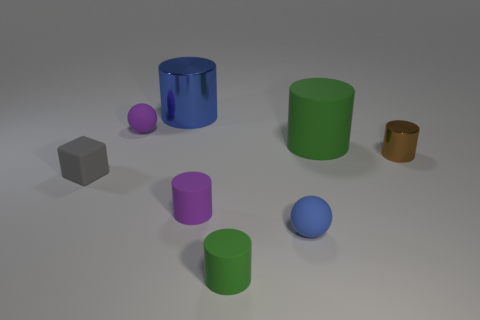How many blue objects are the same material as the gray thing?
Keep it short and to the point. 1. There is a matte ball that is behind the small thing on the right side of the big green cylinder; what is its size?
Keep it short and to the point. Small. The small object that is both behind the gray rubber cube and to the left of the tiny brown cylinder is what color?
Ensure brevity in your answer.  Purple. Does the tiny gray rubber thing have the same shape as the blue matte thing?
Keep it short and to the point. No. What is the size of the other cylinder that is the same color as the large rubber cylinder?
Your answer should be compact. Small. What shape is the tiny gray object left of the sphere on the right side of the small green rubber cylinder?
Provide a short and direct response. Cube. There is a small blue thing; is its shape the same as the blue object left of the small purple cylinder?
Your answer should be compact. No. There is another matte sphere that is the same size as the blue matte sphere; what color is it?
Offer a terse response. Purple. Are there fewer tiny gray matte cubes that are behind the large blue cylinder than blue things behind the small purple sphere?
Offer a terse response. Yes. There is a small purple thing in front of the green rubber cylinder that is behind the matte cylinder in front of the blue rubber thing; what shape is it?
Ensure brevity in your answer.  Cylinder. 